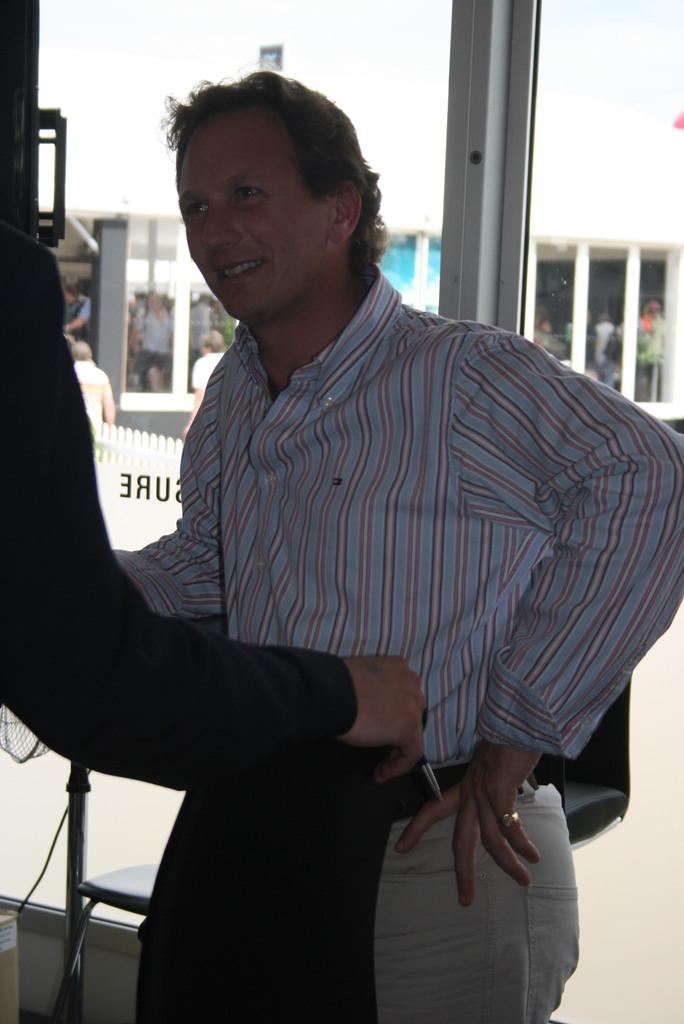What is the main subject of the image? The main subject of the image is a man standing in the middle. What is the man wearing in the image? The man is wearing a shirt and a trouser. What can be seen in the background of the image? There are glass walls and people in the background of the image. What type of tray is the man holding in the image? There is no tray present in the image; the man is not holding anything. Is the man taking a bath in the image? There is no indication of a bath or any water-related activity in the image. 